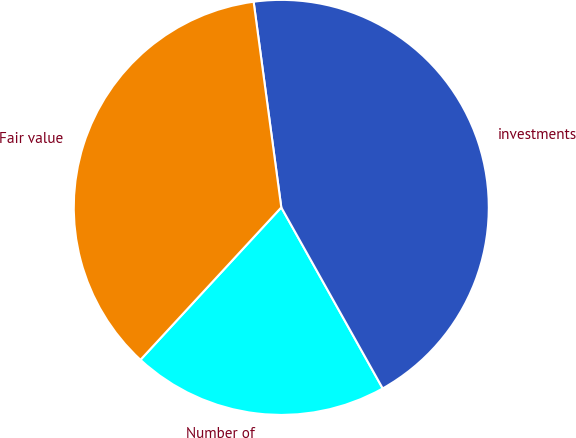Convert chart. <chart><loc_0><loc_0><loc_500><loc_500><pie_chart><fcel>Number of<fcel>investments<fcel>Fair value<nl><fcel>20.0%<fcel>44.0%<fcel>36.0%<nl></chart> 